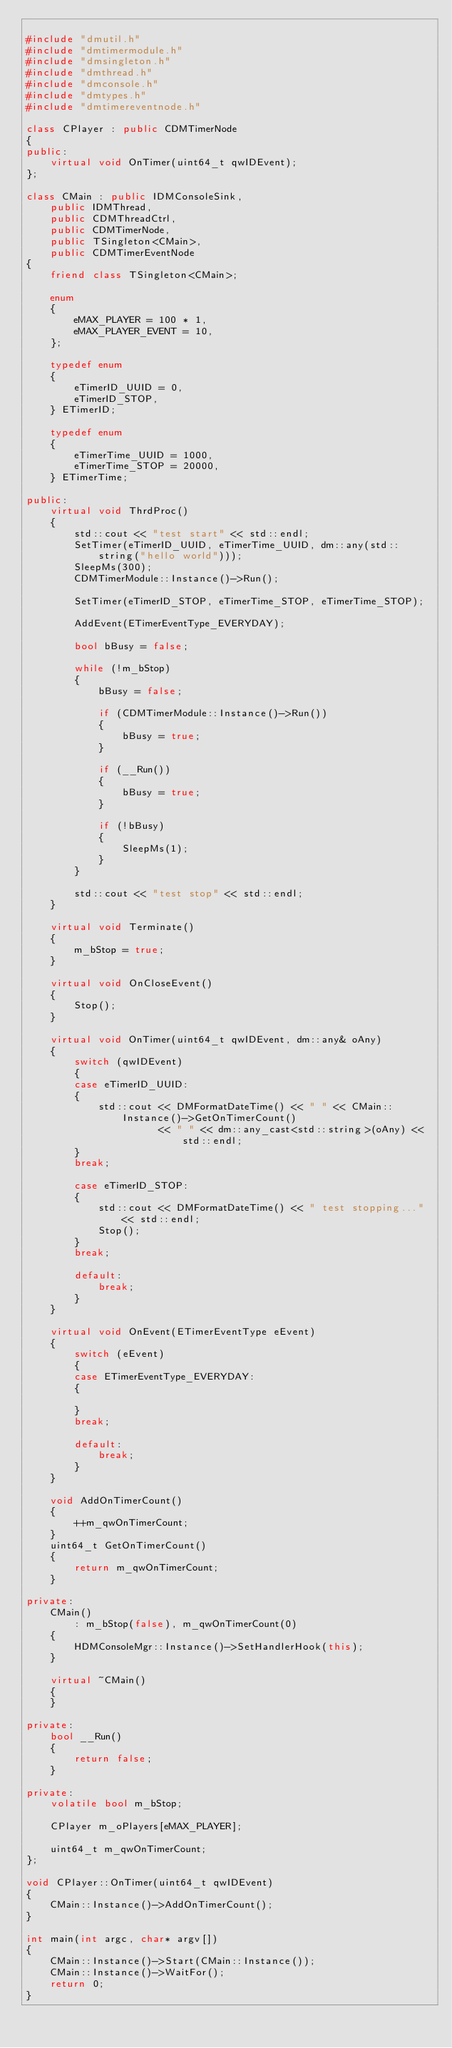Convert code to text. <code><loc_0><loc_0><loc_500><loc_500><_C++_>
#include "dmutil.h"
#include "dmtimermodule.h"
#include "dmsingleton.h"
#include "dmthread.h"
#include "dmconsole.h"
#include "dmtypes.h"
#include "dmtimereventnode.h"

class CPlayer : public CDMTimerNode
{
public:
    virtual void OnTimer(uint64_t qwIDEvent);
};

class CMain : public IDMConsoleSink,
    public IDMThread,
    public CDMThreadCtrl,
    public CDMTimerNode,
    public TSingleton<CMain>,
    public CDMTimerEventNode
{
    friend class TSingleton<CMain>;

    enum
    {
        eMAX_PLAYER = 100 * 1,
        eMAX_PLAYER_EVENT = 10,
    };

    typedef enum
    {
        eTimerID_UUID = 0,
        eTimerID_STOP,
    } ETimerID;

    typedef enum
    {
        eTimerTime_UUID = 1000,
        eTimerTime_STOP = 20000,
    } ETimerTime;

public:
    virtual void ThrdProc()
    {
        std::cout << "test start" << std::endl;
        SetTimer(eTimerID_UUID, eTimerTime_UUID, dm::any(std::string("hello world")));
        SleepMs(300);
        CDMTimerModule::Instance()->Run();

        SetTimer(eTimerID_STOP, eTimerTime_STOP, eTimerTime_STOP);

        AddEvent(ETimerEventType_EVERYDAY);
        
        bool bBusy = false;

        while (!m_bStop)
        {
            bBusy = false;

            if (CDMTimerModule::Instance()->Run())
            {
                bBusy = true;
            }

            if (__Run())
            {
                bBusy = true;
            }

            if (!bBusy)
            {
                SleepMs(1);
            }
        }

        std::cout << "test stop" << std::endl;
    }

    virtual void Terminate()
    {
        m_bStop = true;
    }

    virtual void OnCloseEvent()
    {
        Stop();
    }

    virtual void OnTimer(uint64_t qwIDEvent, dm::any& oAny)
    {
        switch (qwIDEvent)
        {
        case eTimerID_UUID:
        {
            std::cout << DMFormatDateTime() << " " << CMain::Instance()->GetOnTimerCount()
                      << " " << dm::any_cast<std::string>(oAny) << std::endl;
        }
        break;

        case eTimerID_STOP:
        {
            std::cout << DMFormatDateTime() << " test stopping..." << std::endl;
            Stop();
        }
        break;

        default:
            break;
        }
    }

    virtual void OnEvent(ETimerEventType eEvent)
    {
        switch (eEvent)
        {
        case ETimerEventType_EVERYDAY:
        {

        }
        break;

        default:
            break;
        }
    }

    void AddOnTimerCount()
    {
        ++m_qwOnTimerCount;
    }
    uint64_t GetOnTimerCount()
    {
        return m_qwOnTimerCount;
    }

private:
    CMain()
        : m_bStop(false), m_qwOnTimerCount(0)
    {
        HDMConsoleMgr::Instance()->SetHandlerHook(this);
    }

    virtual ~CMain()
    {
    }

private:
    bool __Run()
    {
        return false;
    }

private:
    volatile bool m_bStop;

    CPlayer m_oPlayers[eMAX_PLAYER];

    uint64_t m_qwOnTimerCount;
};

void CPlayer::OnTimer(uint64_t qwIDEvent)
{
    CMain::Instance()->AddOnTimerCount();
}

int main(int argc, char* argv[])
{
    CMain::Instance()->Start(CMain::Instance());
    CMain::Instance()->WaitFor();
    return 0;
}
</code> 